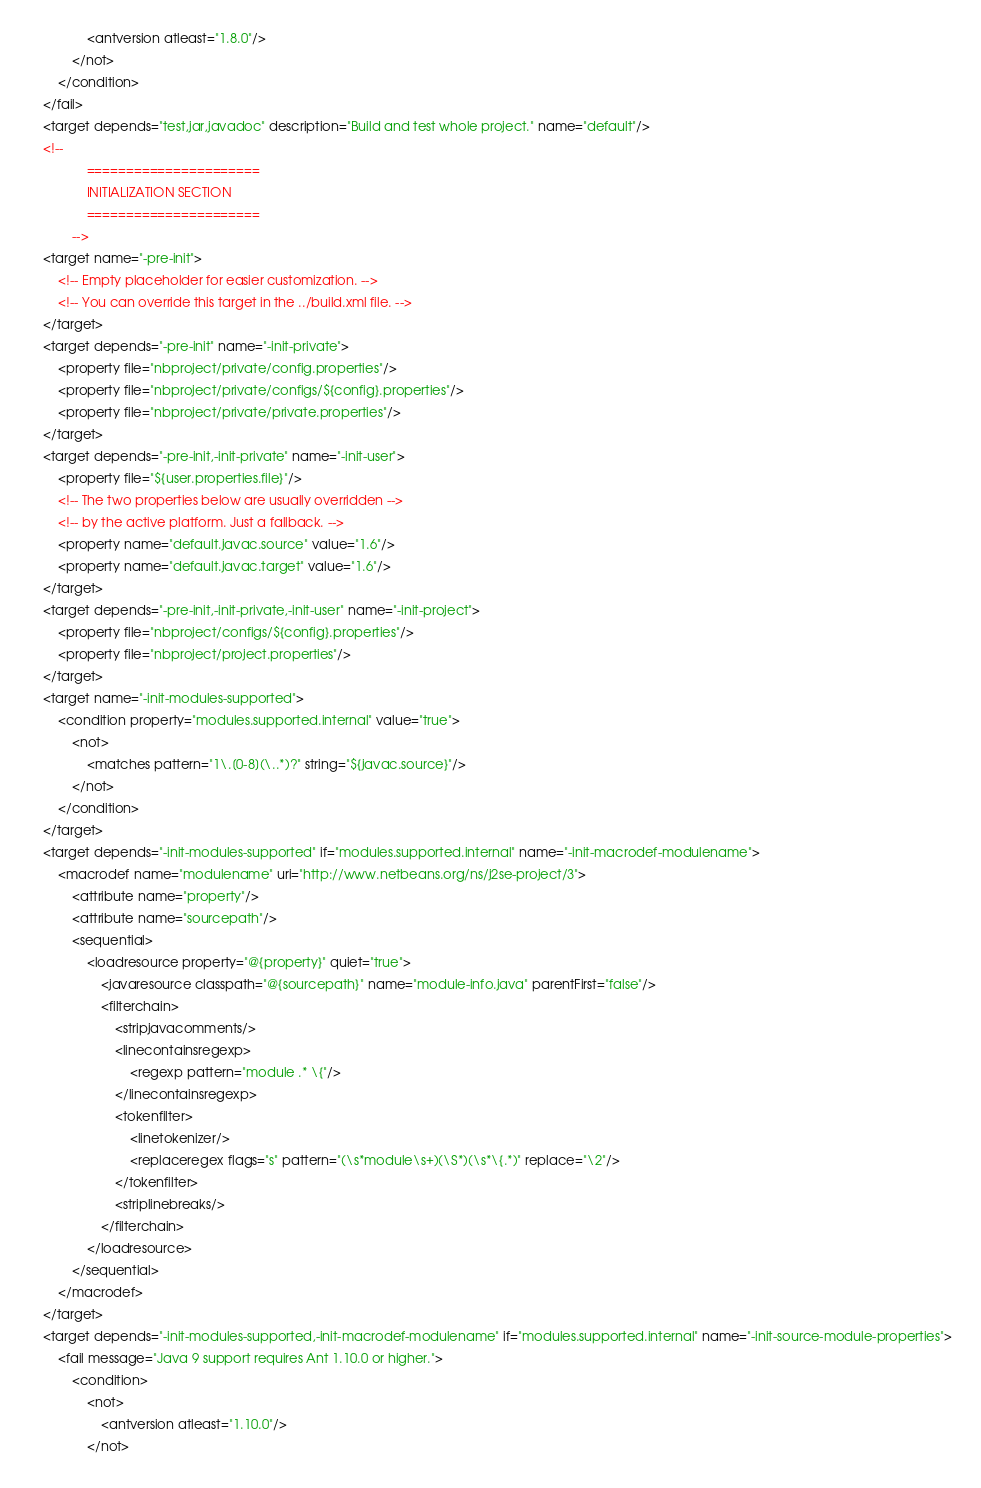<code> <loc_0><loc_0><loc_500><loc_500><_XML_>                <antversion atleast="1.8.0"/>
            </not>
        </condition>
    </fail>
    <target depends="test,jar,javadoc" description="Build and test whole project." name="default"/>
    <!-- 
                ======================
                INITIALIZATION SECTION 
                ======================
            -->
    <target name="-pre-init">
        <!-- Empty placeholder for easier customization. -->
        <!-- You can override this target in the ../build.xml file. -->
    </target>
    <target depends="-pre-init" name="-init-private">
        <property file="nbproject/private/config.properties"/>
        <property file="nbproject/private/configs/${config}.properties"/>
        <property file="nbproject/private/private.properties"/>
    </target>
    <target depends="-pre-init,-init-private" name="-init-user">
        <property file="${user.properties.file}"/>
        <!-- The two properties below are usually overridden -->
        <!-- by the active platform. Just a fallback. -->
        <property name="default.javac.source" value="1.6"/>
        <property name="default.javac.target" value="1.6"/>
    </target>
    <target depends="-pre-init,-init-private,-init-user" name="-init-project">
        <property file="nbproject/configs/${config}.properties"/>
        <property file="nbproject/project.properties"/>
    </target>
    <target name="-init-modules-supported">
        <condition property="modules.supported.internal" value="true">
            <not>
                <matches pattern="1\.[0-8](\..*)?" string="${javac.source}"/>
            </not>
        </condition>
    </target>
    <target depends="-init-modules-supported" if="modules.supported.internal" name="-init-macrodef-modulename">
        <macrodef name="modulename" uri="http://www.netbeans.org/ns/j2se-project/3">
            <attribute name="property"/>
            <attribute name="sourcepath"/>
            <sequential>
                <loadresource property="@{property}" quiet="true">
                    <javaresource classpath="@{sourcepath}" name="module-info.java" parentFirst="false"/>
                    <filterchain>
                        <stripjavacomments/>
                        <linecontainsregexp>
                            <regexp pattern="module .* \{"/>
                        </linecontainsregexp>
                        <tokenfilter>
                            <linetokenizer/>
                            <replaceregex flags="s" pattern="(\s*module\s+)(\S*)(\s*\{.*)" replace="\2"/>
                        </tokenfilter>
                        <striplinebreaks/>
                    </filterchain>
                </loadresource>
            </sequential>
        </macrodef>
    </target>
    <target depends="-init-modules-supported,-init-macrodef-modulename" if="modules.supported.internal" name="-init-source-module-properties">
        <fail message="Java 9 support requires Ant 1.10.0 or higher.">
            <condition>
                <not>
                    <antversion atleast="1.10.0"/>
                </not></code> 